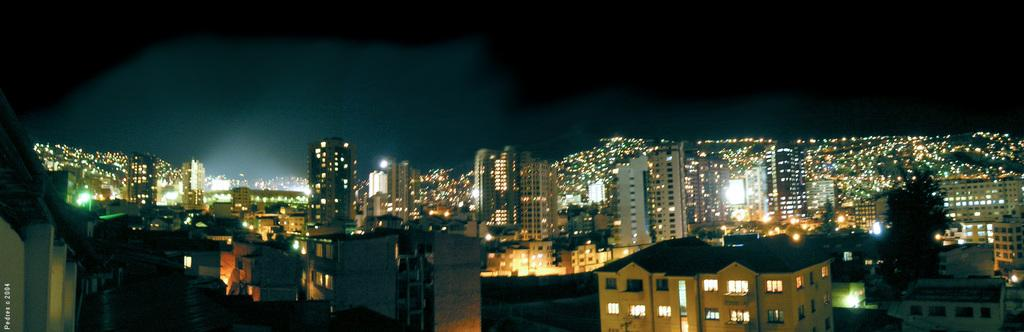What time of day is depicted in the image? The image is taken at nighttime. What can be seen in the image besides the night sky? There are many buildings in the image. What feature of the buildings is visible in the image? The buildings have lights. What type of ring can be seen on the insect's leg in the image? There is no insect or ring present in the image; it features buildings at nighttime. 